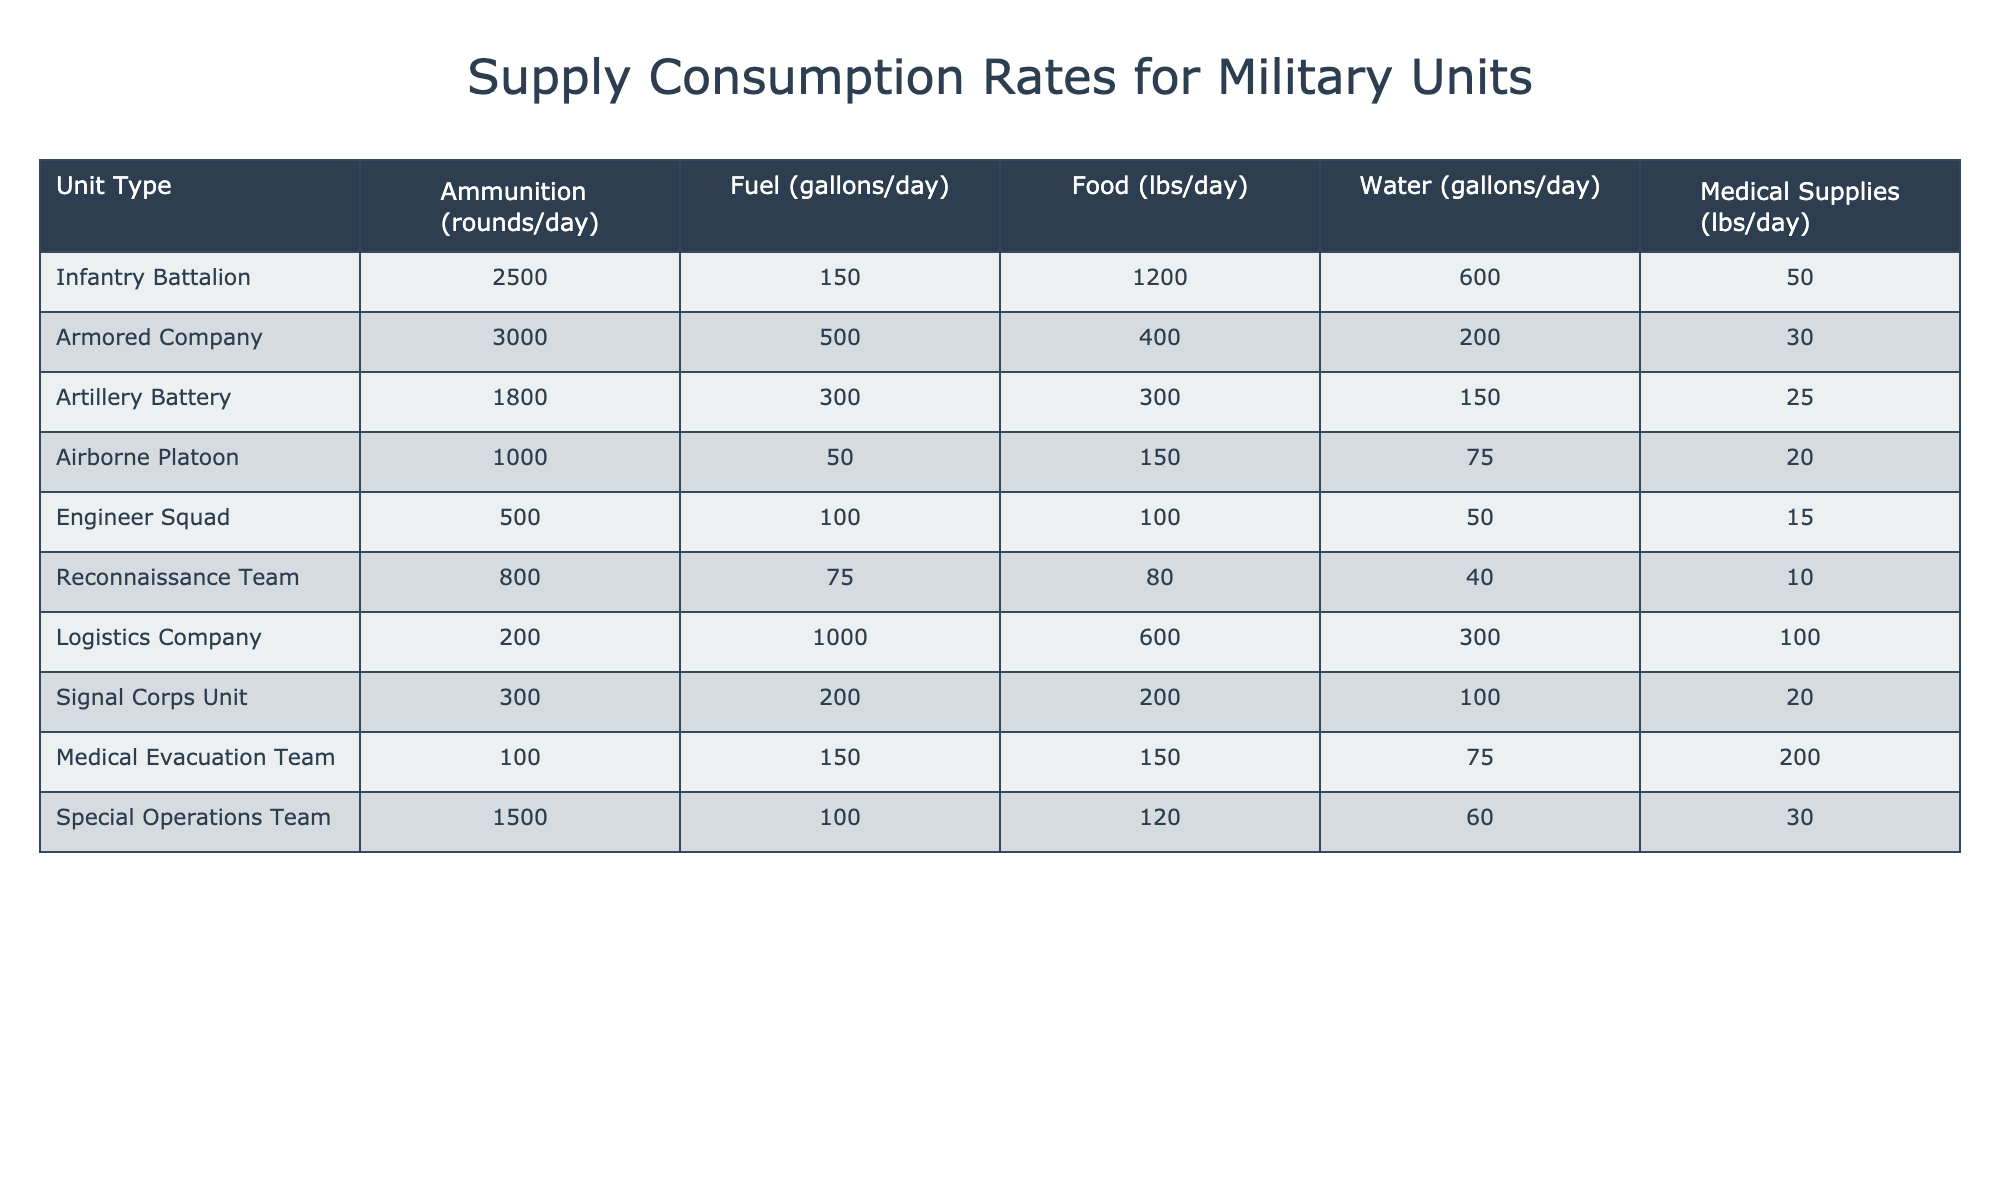What is the ammunition consumption rate for an Infantry Battalion? The table shows that the ammunition consumption rate for an Infantry Battalion is listed under the "Ammunition" column. By directly referencing the table, the value is found to be 2500 rounds/day.
Answer: 2500 rounds/day How much fuel does an Armored Company consume daily? The table indicates the daily fuel consumption for an Armored Company in the "Fuel" column, which is 500 gallons/day.
Answer: 500 gallons/day Which unit has the highest food consumption? By comparing the values in the "Food" column, it can be observed that the Infantry Battalion consumes the most food at 1200 lbs/day.
Answer: Infantry Battalion What is the average water consumption for all units combined? The water consumption values are 600, 200, 150, 75, 50, 40, 300, 100, 75, and 60 gallons/day respectively. The sum is 2000 gallons (600+200+150+75+50+40+300+100+75+60) divided by 10 units equals 200 gallons/day, which is the average.
Answer: 200 gallons/day Does the Logistics Company consume more ammunition than the Airborne Platoon? The ammunition consumption for the Logistics Company is 200 rounds/day, while the Airborne Platoon consumes 1000 rounds/day. Since 200 < 1000, the answer is yes.
Answer: Yes What is the total consumption of medical supplies by the Special Operations Team and the Medical Evacuation Team? From the table, the Special Operations Team consumes 30 lbs/day and the Medical Evacuation Team consumes 200 lbs/day. Adding these values gives 30 + 200 = 230 lbs/day as the total medical supplies consumption.
Answer: 230 lbs/day How much more water does an Infantry Battalion consume compared to a Reconnaissance Team? The Infantry Battalion consumes 600 gallons/day of water, while the Reconnaissance Team consumes 40 gallons/day. The difference is 600 - 40 = 560 gallons/day.
Answer: 560 gallons/day What percentage of fuel does an Artillery Battery consume compared to the Armored Company? The Artillery Battery consumes 300 gallons/day, and the Armored Company consumes 500 gallons/day. To find the percentage, calculate (300 / 500) * 100 = 60%.
Answer: 60% Which unit has the lowest medical supplies requirement? The table lists the medical supplies requirement for each unit, with the Engineer Squad consuming only 15 lbs/day, which is the lowest among all the units.
Answer: Engineer Squad If you combine the food consumption of the Logistics Company and the Armored Company, how does it compare to that of the Infantry Battalion? The Logistics Company consumes 600 lbs/day and the Armored Company consumes 400 lbs/day. Combining both gives 600 + 400 = 1000 lbs/day, which is still less than the Infantry Battalion's consumption of 1200 lbs/day.
Answer: Less than Infantry Battalion 